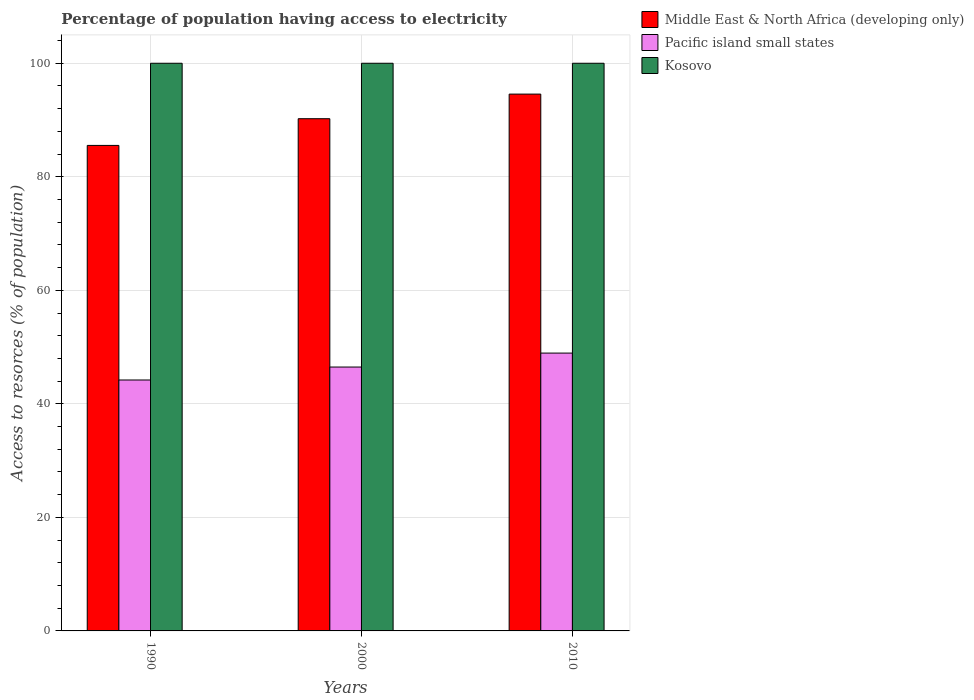How many different coloured bars are there?
Provide a succinct answer. 3. How many groups of bars are there?
Offer a very short reply. 3. Are the number of bars per tick equal to the number of legend labels?
Your answer should be very brief. Yes. What is the label of the 3rd group of bars from the left?
Make the answer very short. 2010. In how many cases, is the number of bars for a given year not equal to the number of legend labels?
Ensure brevity in your answer.  0. What is the percentage of population having access to electricity in Middle East & North Africa (developing only) in 1990?
Make the answer very short. 85.53. Across all years, what is the maximum percentage of population having access to electricity in Pacific island small states?
Your answer should be compact. 48.94. Across all years, what is the minimum percentage of population having access to electricity in Pacific island small states?
Make the answer very short. 44.2. In which year was the percentage of population having access to electricity in Middle East & North Africa (developing only) minimum?
Your response must be concise. 1990. What is the total percentage of population having access to electricity in Middle East & North Africa (developing only) in the graph?
Offer a very short reply. 270.32. What is the difference between the percentage of population having access to electricity in Kosovo in 1990 and that in 2000?
Make the answer very short. 0. What is the difference between the percentage of population having access to electricity in Pacific island small states in 2000 and the percentage of population having access to electricity in Middle East & North Africa (developing only) in 1990?
Your response must be concise. -39.04. What is the average percentage of population having access to electricity in Middle East & North Africa (developing only) per year?
Provide a succinct answer. 90.11. In the year 2000, what is the difference between the percentage of population having access to electricity in Kosovo and percentage of population having access to electricity in Middle East & North Africa (developing only)?
Provide a succinct answer. 9.77. What is the difference between the highest and the second highest percentage of population having access to electricity in Pacific island small states?
Keep it short and to the point. 2.46. What is the difference between the highest and the lowest percentage of population having access to electricity in Kosovo?
Offer a very short reply. 0. In how many years, is the percentage of population having access to electricity in Kosovo greater than the average percentage of population having access to electricity in Kosovo taken over all years?
Keep it short and to the point. 0. Is the sum of the percentage of population having access to electricity in Middle East & North Africa (developing only) in 2000 and 2010 greater than the maximum percentage of population having access to electricity in Kosovo across all years?
Keep it short and to the point. Yes. What does the 2nd bar from the left in 1990 represents?
Make the answer very short. Pacific island small states. What does the 1st bar from the right in 2010 represents?
Make the answer very short. Kosovo. How many years are there in the graph?
Your answer should be compact. 3. Are the values on the major ticks of Y-axis written in scientific E-notation?
Your answer should be compact. No. Does the graph contain grids?
Make the answer very short. Yes. Where does the legend appear in the graph?
Your answer should be very brief. Top right. How many legend labels are there?
Offer a very short reply. 3. What is the title of the graph?
Ensure brevity in your answer.  Percentage of population having access to electricity. Does "Liechtenstein" appear as one of the legend labels in the graph?
Keep it short and to the point. No. What is the label or title of the Y-axis?
Your answer should be very brief. Access to resorces (% of population). What is the Access to resorces (% of population) in Middle East & North Africa (developing only) in 1990?
Make the answer very short. 85.53. What is the Access to resorces (% of population) in Pacific island small states in 1990?
Keep it short and to the point. 44.2. What is the Access to resorces (% of population) in Middle East & North Africa (developing only) in 2000?
Give a very brief answer. 90.23. What is the Access to resorces (% of population) of Pacific island small states in 2000?
Offer a terse response. 46.48. What is the Access to resorces (% of population) of Kosovo in 2000?
Provide a short and direct response. 100. What is the Access to resorces (% of population) of Middle East & North Africa (developing only) in 2010?
Ensure brevity in your answer.  94.57. What is the Access to resorces (% of population) in Pacific island small states in 2010?
Offer a terse response. 48.94. What is the Access to resorces (% of population) in Kosovo in 2010?
Offer a terse response. 100. Across all years, what is the maximum Access to resorces (% of population) of Middle East & North Africa (developing only)?
Make the answer very short. 94.57. Across all years, what is the maximum Access to resorces (% of population) in Pacific island small states?
Make the answer very short. 48.94. Across all years, what is the minimum Access to resorces (% of population) of Middle East & North Africa (developing only)?
Your answer should be compact. 85.53. Across all years, what is the minimum Access to resorces (% of population) in Pacific island small states?
Provide a succinct answer. 44.2. What is the total Access to resorces (% of population) in Middle East & North Africa (developing only) in the graph?
Ensure brevity in your answer.  270.32. What is the total Access to resorces (% of population) of Pacific island small states in the graph?
Keep it short and to the point. 139.63. What is the total Access to resorces (% of population) in Kosovo in the graph?
Keep it short and to the point. 300. What is the difference between the Access to resorces (% of population) of Middle East & North Africa (developing only) in 1990 and that in 2000?
Provide a succinct answer. -4.7. What is the difference between the Access to resorces (% of population) in Pacific island small states in 1990 and that in 2000?
Offer a terse response. -2.28. What is the difference between the Access to resorces (% of population) of Middle East & North Africa (developing only) in 1990 and that in 2010?
Offer a very short reply. -9.04. What is the difference between the Access to resorces (% of population) of Pacific island small states in 1990 and that in 2010?
Provide a short and direct response. -4.74. What is the difference between the Access to resorces (% of population) in Middle East & North Africa (developing only) in 2000 and that in 2010?
Your answer should be very brief. -4.34. What is the difference between the Access to resorces (% of population) in Pacific island small states in 2000 and that in 2010?
Provide a succinct answer. -2.46. What is the difference between the Access to resorces (% of population) of Kosovo in 2000 and that in 2010?
Offer a terse response. 0. What is the difference between the Access to resorces (% of population) in Middle East & North Africa (developing only) in 1990 and the Access to resorces (% of population) in Pacific island small states in 2000?
Ensure brevity in your answer.  39.04. What is the difference between the Access to resorces (% of population) of Middle East & North Africa (developing only) in 1990 and the Access to resorces (% of population) of Kosovo in 2000?
Offer a terse response. -14.47. What is the difference between the Access to resorces (% of population) of Pacific island small states in 1990 and the Access to resorces (% of population) of Kosovo in 2000?
Provide a short and direct response. -55.8. What is the difference between the Access to resorces (% of population) in Middle East & North Africa (developing only) in 1990 and the Access to resorces (% of population) in Pacific island small states in 2010?
Give a very brief answer. 36.58. What is the difference between the Access to resorces (% of population) of Middle East & North Africa (developing only) in 1990 and the Access to resorces (% of population) of Kosovo in 2010?
Give a very brief answer. -14.47. What is the difference between the Access to resorces (% of population) in Pacific island small states in 1990 and the Access to resorces (% of population) in Kosovo in 2010?
Provide a short and direct response. -55.8. What is the difference between the Access to resorces (% of population) of Middle East & North Africa (developing only) in 2000 and the Access to resorces (% of population) of Pacific island small states in 2010?
Keep it short and to the point. 41.29. What is the difference between the Access to resorces (% of population) of Middle East & North Africa (developing only) in 2000 and the Access to resorces (% of population) of Kosovo in 2010?
Provide a succinct answer. -9.77. What is the difference between the Access to resorces (% of population) of Pacific island small states in 2000 and the Access to resorces (% of population) of Kosovo in 2010?
Your answer should be very brief. -53.52. What is the average Access to resorces (% of population) in Middle East & North Africa (developing only) per year?
Your answer should be compact. 90.11. What is the average Access to resorces (% of population) in Pacific island small states per year?
Make the answer very short. 46.54. In the year 1990, what is the difference between the Access to resorces (% of population) in Middle East & North Africa (developing only) and Access to resorces (% of population) in Pacific island small states?
Ensure brevity in your answer.  41.32. In the year 1990, what is the difference between the Access to resorces (% of population) in Middle East & North Africa (developing only) and Access to resorces (% of population) in Kosovo?
Your response must be concise. -14.47. In the year 1990, what is the difference between the Access to resorces (% of population) of Pacific island small states and Access to resorces (% of population) of Kosovo?
Make the answer very short. -55.8. In the year 2000, what is the difference between the Access to resorces (% of population) of Middle East & North Africa (developing only) and Access to resorces (% of population) of Pacific island small states?
Keep it short and to the point. 43.75. In the year 2000, what is the difference between the Access to resorces (% of population) of Middle East & North Africa (developing only) and Access to resorces (% of population) of Kosovo?
Offer a terse response. -9.77. In the year 2000, what is the difference between the Access to resorces (% of population) of Pacific island small states and Access to resorces (% of population) of Kosovo?
Offer a terse response. -53.52. In the year 2010, what is the difference between the Access to resorces (% of population) of Middle East & North Africa (developing only) and Access to resorces (% of population) of Pacific island small states?
Offer a terse response. 45.62. In the year 2010, what is the difference between the Access to resorces (% of population) of Middle East & North Africa (developing only) and Access to resorces (% of population) of Kosovo?
Ensure brevity in your answer.  -5.43. In the year 2010, what is the difference between the Access to resorces (% of population) of Pacific island small states and Access to resorces (% of population) of Kosovo?
Make the answer very short. -51.06. What is the ratio of the Access to resorces (% of population) of Middle East & North Africa (developing only) in 1990 to that in 2000?
Your answer should be very brief. 0.95. What is the ratio of the Access to resorces (% of population) of Pacific island small states in 1990 to that in 2000?
Your answer should be compact. 0.95. What is the ratio of the Access to resorces (% of population) in Kosovo in 1990 to that in 2000?
Your answer should be very brief. 1. What is the ratio of the Access to resorces (% of population) of Middle East & North Africa (developing only) in 1990 to that in 2010?
Keep it short and to the point. 0.9. What is the ratio of the Access to resorces (% of population) in Pacific island small states in 1990 to that in 2010?
Ensure brevity in your answer.  0.9. What is the ratio of the Access to resorces (% of population) of Middle East & North Africa (developing only) in 2000 to that in 2010?
Your response must be concise. 0.95. What is the ratio of the Access to resorces (% of population) of Pacific island small states in 2000 to that in 2010?
Your answer should be very brief. 0.95. What is the ratio of the Access to resorces (% of population) of Kosovo in 2000 to that in 2010?
Provide a short and direct response. 1. What is the difference between the highest and the second highest Access to resorces (% of population) of Middle East & North Africa (developing only)?
Your response must be concise. 4.34. What is the difference between the highest and the second highest Access to resorces (% of population) in Pacific island small states?
Keep it short and to the point. 2.46. What is the difference between the highest and the lowest Access to resorces (% of population) in Middle East & North Africa (developing only)?
Keep it short and to the point. 9.04. What is the difference between the highest and the lowest Access to resorces (% of population) in Pacific island small states?
Your response must be concise. 4.74. 